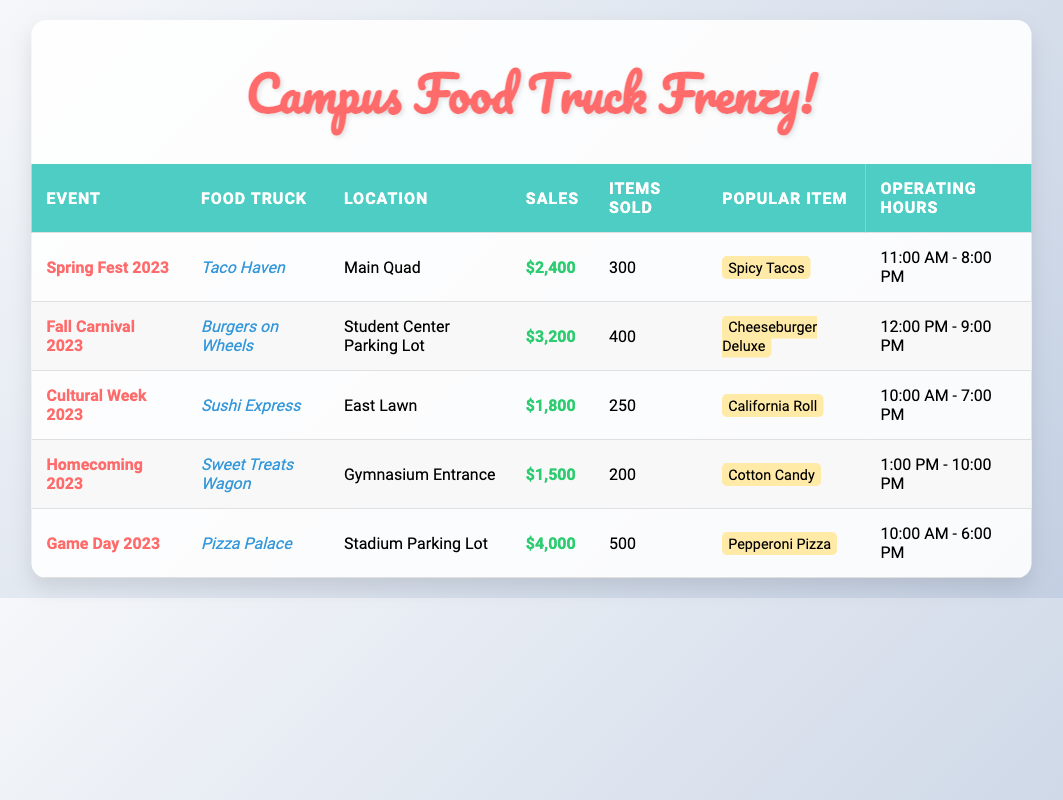What was the sales amount for Taco Haven during Spring Fest 2023? According to the table, Taco Haven's sales amount during Spring Fest 2023 is listed directly in the row corresponding to that event as $2,400.
Answer: $2,400 Which food truck had the highest sales amount? To find the highest sales amount, we compare the values in the sales column. The food truck with the highest sales figure is Pizza Palace, with $4,000 during Game Day 2023.
Answer: Pizza Palace How many items were sold altogether across all food trucks at the festivals? We sum up the items sold for all food trucks: 300 (Taco Haven) + 400 (Burgers on Wheels) + 250 (Sushi Express) + 200 (Sweet Treats Wagon) + 500 (Pizza Palace) = 1,650.
Answer: 1,650 Is the popular item for Sweet Treats Wagon cotton candy? Looking at the row for Sweet Treats Wagon in the table, it clearly states that the popular item is cotton candy, so the answer is yes.
Answer: Yes What is the average sales amount of all food trucks during the events? To find the average sales amount, first sum all sales: $2,400 + $3,200 + $1,800 + $1,500 + $4,000 = $13,900. Next, divide by the number of food trucks (5): $13,900 / 5 = $2,780.
Answer: $2,780 During which event did Sushi Express operate, and what were its operating hours? Sushi Express is associated with the event Cultural Week 2023, and according to its row, it operated from 10:00 AM to 7:00 PM.
Answer: Cultural Week 2023, 10:00 AM - 7:00 PM What is the total sales amount for food trucks located at the Student Center Parking Lot and Gymnasium Entrance combined? The food trucks listed at these locations are Burgers on Wheels with $3,200 and Sweet Treats Wagon with $1,500. Their combined sales amount is $3,200 + $1,500 = $4,700.
Answer: $4,700 Did any food truck sell fewer than 250 items during the events? By reviewing the items sold for each truck, the Sweet Treats Wagon sold 200 items, which is fewer than 250. So, the conclusion is yes.
Answer: Yes How many hours did Taco Haven operate during the festival? From the table, Taco Haven's operating hours during Spring Fest 2023 are listed as 11:00 AM to 8:00 PM. This is a total of 9 hours (from 11:00 AM to 8:00 PM).
Answer: 9 hours 